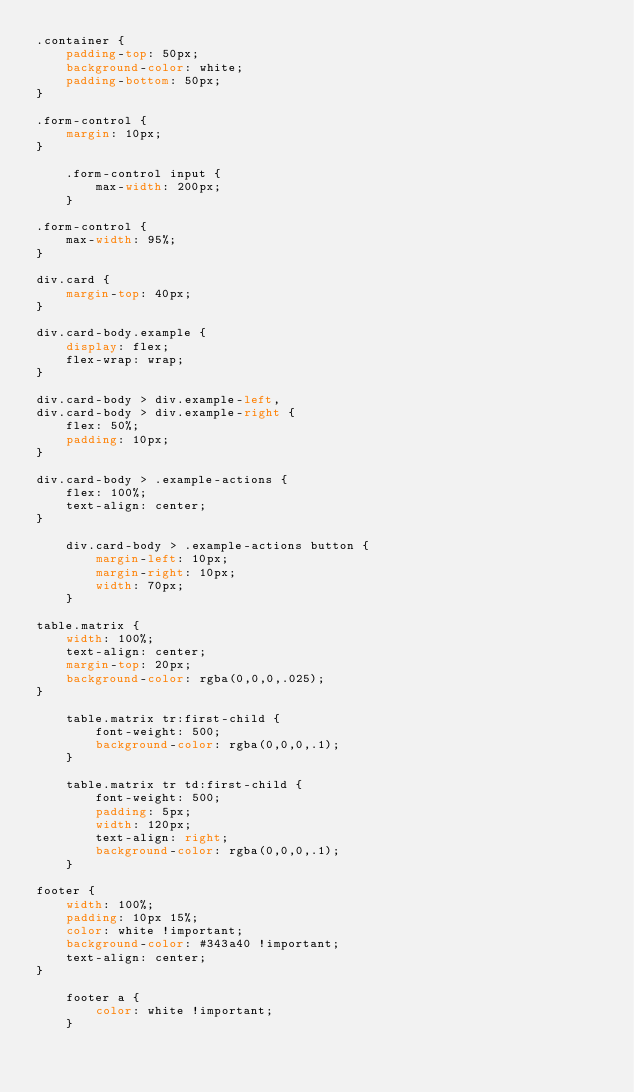<code> <loc_0><loc_0><loc_500><loc_500><_CSS_>.container {
    padding-top: 50px;
    background-color: white;
    padding-bottom: 50px;
}

.form-control {
    margin: 10px;
}

    .form-control input {
        max-width: 200px;
    }

.form-control {
    max-width: 95%;
}

div.card {
    margin-top: 40px;
}

div.card-body.example {
    display: flex;
    flex-wrap: wrap;
}

div.card-body > div.example-left,
div.card-body > div.example-right {
    flex: 50%;
    padding: 10px;
}

div.card-body > .example-actions {
    flex: 100%;
    text-align: center;
}

    div.card-body > .example-actions button {
        margin-left: 10px;
        margin-right: 10px;
        width: 70px;
    }

table.matrix {
    width: 100%;
    text-align: center;
    margin-top: 20px;
    background-color: rgba(0,0,0,.025);
}

    table.matrix tr:first-child {
        font-weight: 500;
        background-color: rgba(0,0,0,.1);
    }

    table.matrix tr td:first-child {
        font-weight: 500;
        padding: 5px;
        width: 120px;
        text-align: right;
        background-color: rgba(0,0,0,.1);
    }

footer {
    width: 100%;
    padding: 10px 15%;
    color: white !important;
    background-color: #343a40 !important;
    text-align: center;
}

    footer a {
        color: white !important;
    }
</code> 